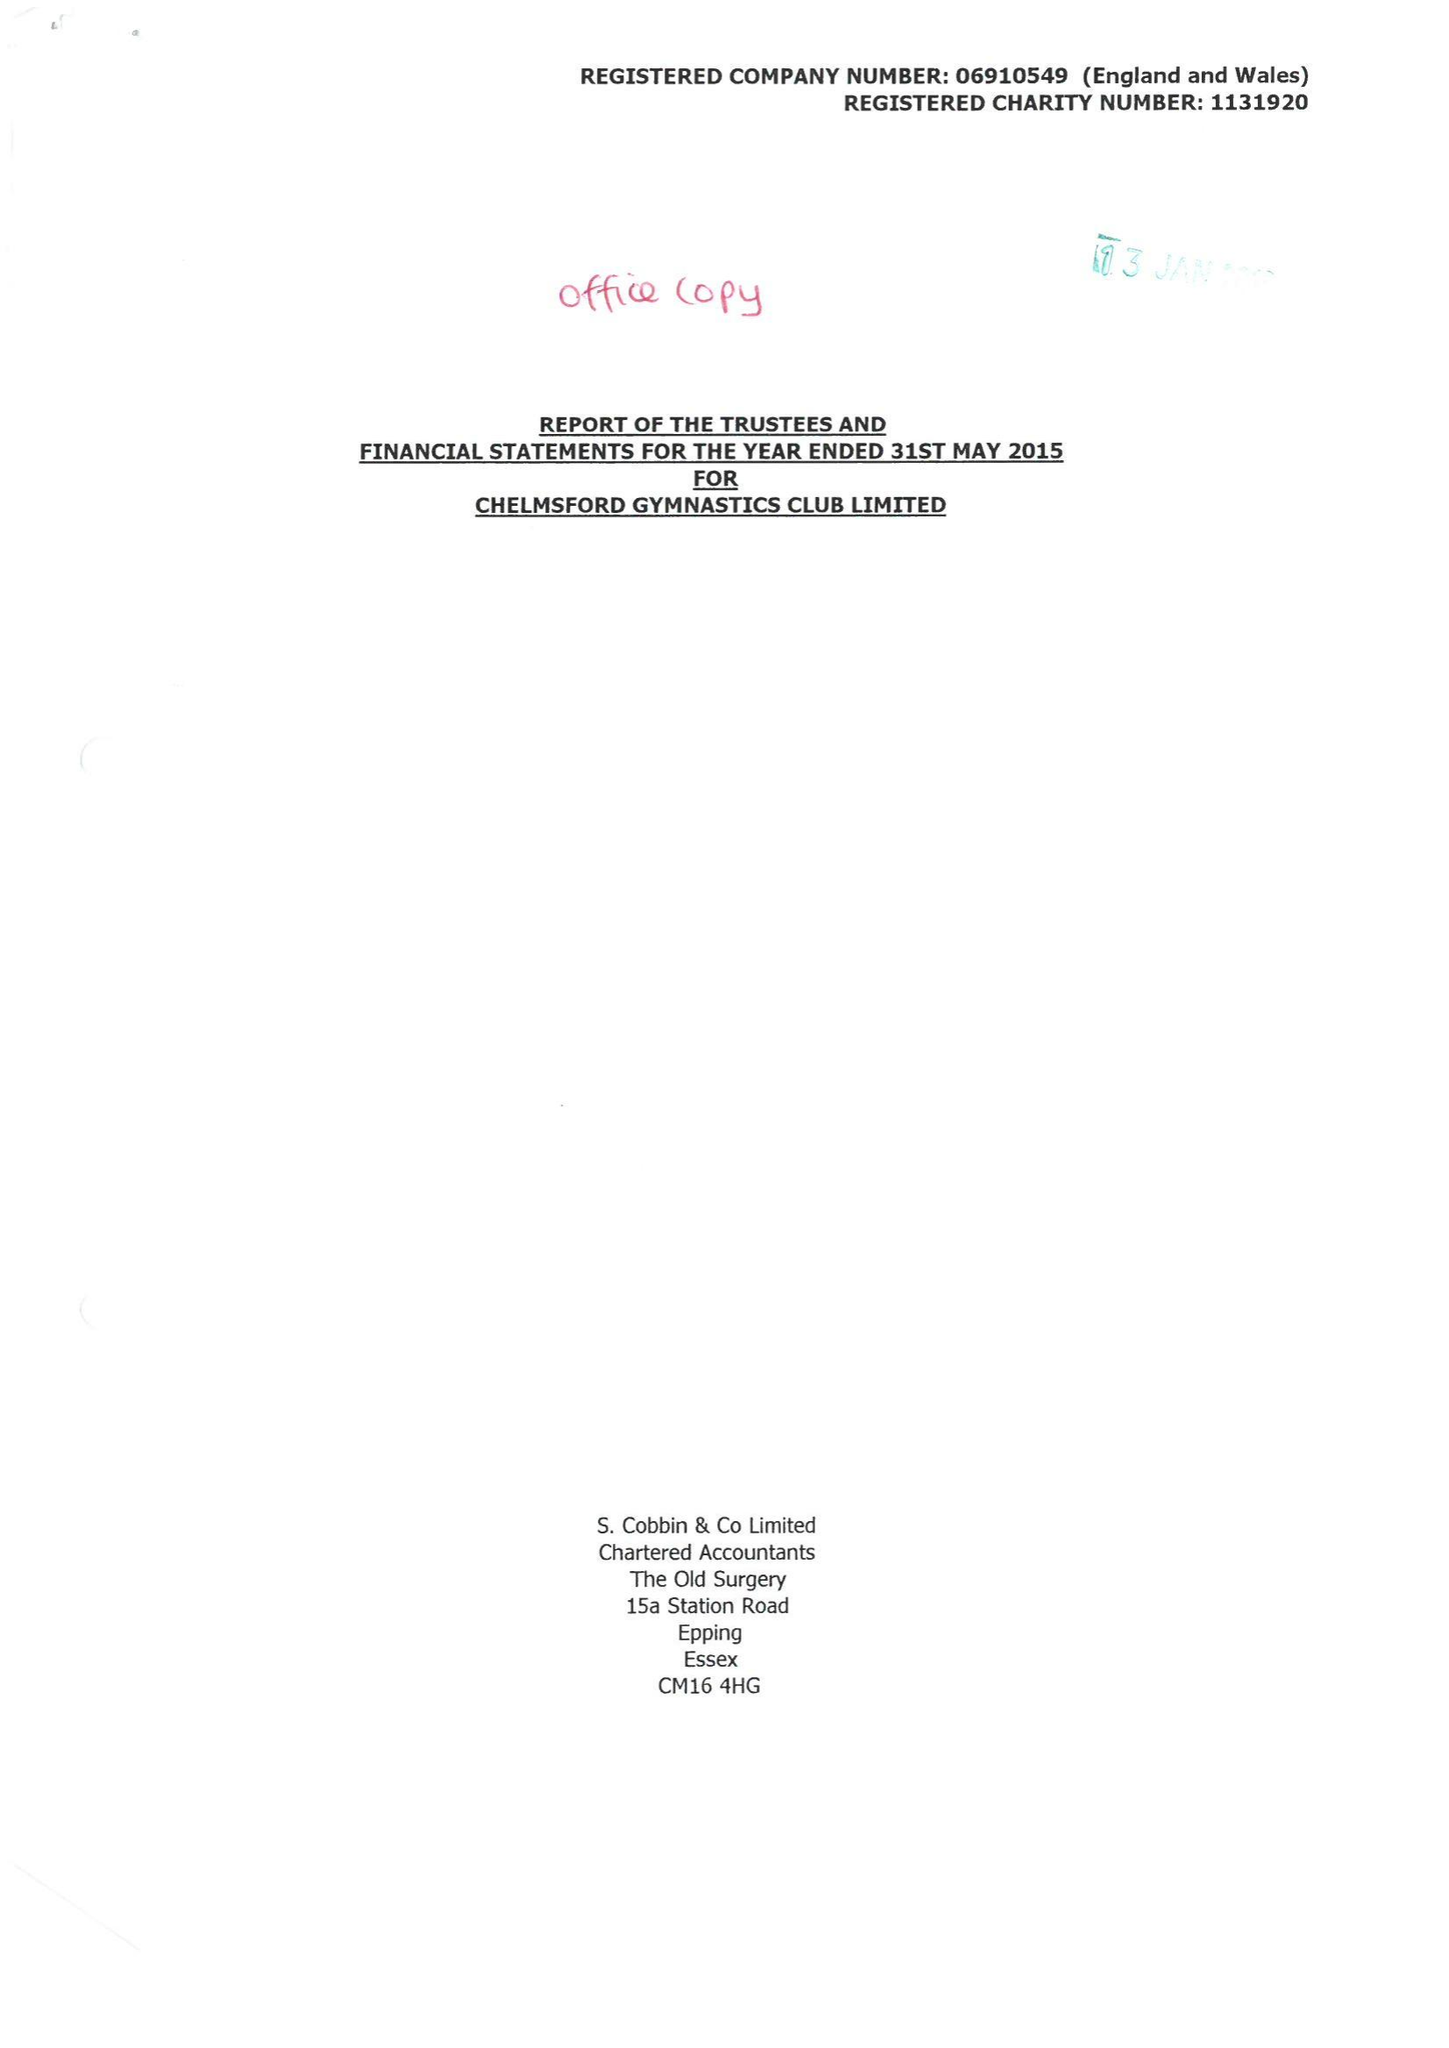What is the value for the address__street_line?
Answer the question using a single word or phrase. 9 THE HEYTHROP 